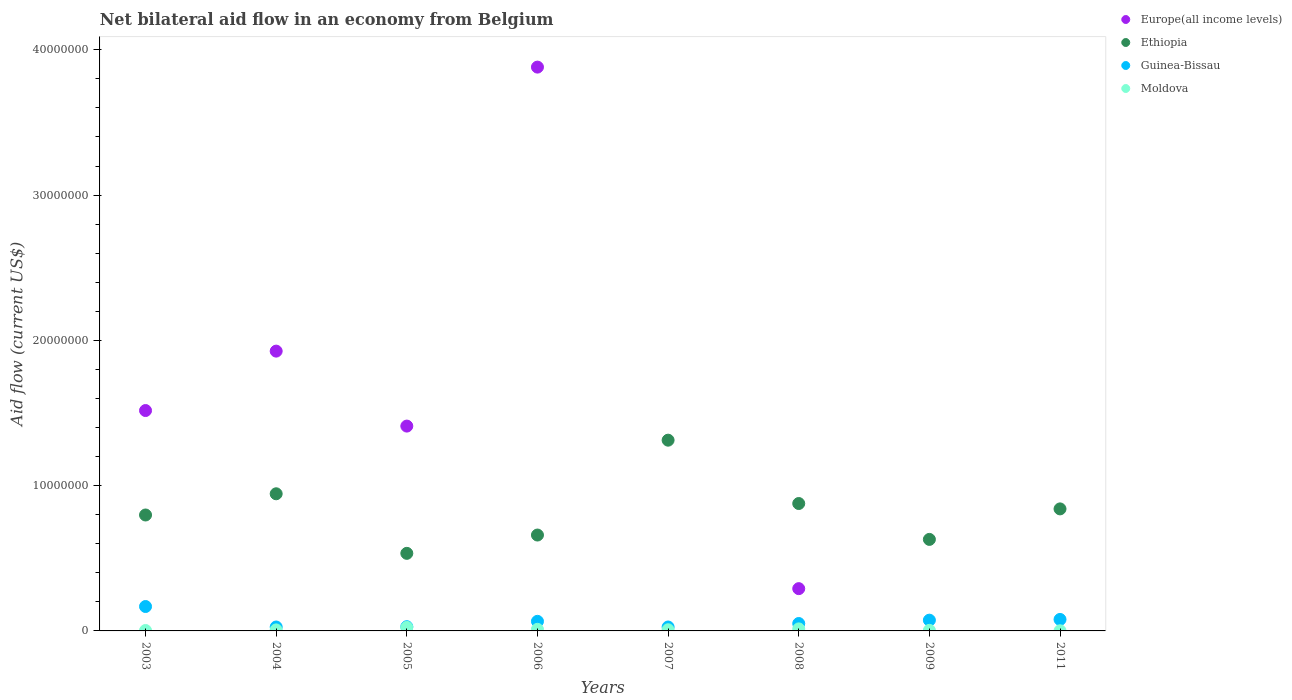How many different coloured dotlines are there?
Your answer should be compact. 4. Is the number of dotlines equal to the number of legend labels?
Make the answer very short. No. What is the net bilateral aid flow in Europe(all income levels) in 2009?
Give a very brief answer. 0. Across all years, what is the maximum net bilateral aid flow in Guinea-Bissau?
Offer a terse response. 1.68e+06. Across all years, what is the minimum net bilateral aid flow in Moldova?
Ensure brevity in your answer.  10000. What is the total net bilateral aid flow in Moldova in the graph?
Your answer should be very brief. 7.20e+05. What is the difference between the net bilateral aid flow in Moldova in 2006 and the net bilateral aid flow in Europe(all income levels) in 2009?
Offer a very short reply. 1.10e+05. What is the average net bilateral aid flow in Europe(all income levels) per year?
Ensure brevity in your answer.  1.13e+07. In the year 2004, what is the difference between the net bilateral aid flow in Europe(all income levels) and net bilateral aid flow in Guinea-Bissau?
Offer a very short reply. 1.90e+07. Is the net bilateral aid flow in Ethiopia in 2005 less than that in 2006?
Provide a succinct answer. Yes. What is the difference between the highest and the second highest net bilateral aid flow in Moldova?
Your answer should be compact. 1.00e+05. What is the difference between the highest and the lowest net bilateral aid flow in Europe(all income levels)?
Provide a succinct answer. 3.88e+07. Is it the case that in every year, the sum of the net bilateral aid flow in Guinea-Bissau and net bilateral aid flow in Moldova  is greater than the sum of net bilateral aid flow in Europe(all income levels) and net bilateral aid flow in Ethiopia?
Make the answer very short. No. Is it the case that in every year, the sum of the net bilateral aid flow in Moldova and net bilateral aid flow in Guinea-Bissau  is greater than the net bilateral aid flow in Europe(all income levels)?
Keep it short and to the point. No. Is the net bilateral aid flow in Guinea-Bissau strictly less than the net bilateral aid flow in Europe(all income levels) over the years?
Your answer should be very brief. No. How many dotlines are there?
Ensure brevity in your answer.  4. What is the difference between two consecutive major ticks on the Y-axis?
Provide a short and direct response. 1.00e+07. Are the values on the major ticks of Y-axis written in scientific E-notation?
Your answer should be compact. No. Does the graph contain grids?
Provide a succinct answer. No. Where does the legend appear in the graph?
Provide a succinct answer. Top right. What is the title of the graph?
Offer a very short reply. Net bilateral aid flow in an economy from Belgium. Does "Czech Republic" appear as one of the legend labels in the graph?
Make the answer very short. No. What is the label or title of the X-axis?
Your answer should be very brief. Years. What is the label or title of the Y-axis?
Ensure brevity in your answer.  Aid flow (current US$). What is the Aid flow (current US$) in Europe(all income levels) in 2003?
Your answer should be compact. 1.52e+07. What is the Aid flow (current US$) in Ethiopia in 2003?
Your answer should be compact. 7.98e+06. What is the Aid flow (current US$) of Guinea-Bissau in 2003?
Your answer should be very brief. 1.68e+06. What is the Aid flow (current US$) of Europe(all income levels) in 2004?
Your response must be concise. 1.93e+07. What is the Aid flow (current US$) of Ethiopia in 2004?
Your answer should be compact. 9.44e+06. What is the Aid flow (current US$) in Europe(all income levels) in 2005?
Your answer should be very brief. 1.41e+07. What is the Aid flow (current US$) of Ethiopia in 2005?
Your response must be concise. 5.34e+06. What is the Aid flow (current US$) of Guinea-Bissau in 2005?
Provide a short and direct response. 2.90e+05. What is the Aid flow (current US$) in Europe(all income levels) in 2006?
Keep it short and to the point. 3.88e+07. What is the Aid flow (current US$) in Ethiopia in 2006?
Your answer should be very brief. 6.60e+06. What is the Aid flow (current US$) of Guinea-Bissau in 2006?
Make the answer very short. 6.60e+05. What is the Aid flow (current US$) in Moldova in 2006?
Offer a very short reply. 1.10e+05. What is the Aid flow (current US$) in Ethiopia in 2007?
Keep it short and to the point. 1.31e+07. What is the Aid flow (current US$) in Guinea-Bissau in 2007?
Your answer should be compact. 2.70e+05. What is the Aid flow (current US$) of Moldova in 2007?
Your response must be concise. 8.00e+04. What is the Aid flow (current US$) in Europe(all income levels) in 2008?
Offer a terse response. 2.91e+06. What is the Aid flow (current US$) of Ethiopia in 2008?
Your response must be concise. 8.77e+06. What is the Aid flow (current US$) in Guinea-Bissau in 2008?
Offer a terse response. 5.10e+05. What is the Aid flow (current US$) of Moldova in 2008?
Your answer should be very brief. 1.40e+05. What is the Aid flow (current US$) in Ethiopia in 2009?
Provide a succinct answer. 6.30e+06. What is the Aid flow (current US$) of Guinea-Bissau in 2009?
Your response must be concise. 7.40e+05. What is the Aid flow (current US$) in Moldova in 2009?
Ensure brevity in your answer.  4.00e+04. What is the Aid flow (current US$) of Europe(all income levels) in 2011?
Ensure brevity in your answer.  0. What is the Aid flow (current US$) in Ethiopia in 2011?
Make the answer very short. 8.40e+06. What is the Aid flow (current US$) of Guinea-Bissau in 2011?
Your answer should be compact. 7.90e+05. What is the Aid flow (current US$) of Moldova in 2011?
Provide a short and direct response. 10000. Across all years, what is the maximum Aid flow (current US$) in Europe(all income levels)?
Give a very brief answer. 3.88e+07. Across all years, what is the maximum Aid flow (current US$) of Ethiopia?
Your answer should be very brief. 1.31e+07. Across all years, what is the maximum Aid flow (current US$) in Guinea-Bissau?
Ensure brevity in your answer.  1.68e+06. Across all years, what is the minimum Aid flow (current US$) of Europe(all income levels)?
Offer a very short reply. 0. Across all years, what is the minimum Aid flow (current US$) of Ethiopia?
Give a very brief answer. 5.34e+06. Across all years, what is the minimum Aid flow (current US$) of Guinea-Bissau?
Your answer should be compact. 2.70e+05. What is the total Aid flow (current US$) in Europe(all income levels) in the graph?
Provide a short and direct response. 9.02e+07. What is the total Aid flow (current US$) in Ethiopia in the graph?
Give a very brief answer. 6.60e+07. What is the total Aid flow (current US$) of Guinea-Bissau in the graph?
Ensure brevity in your answer.  5.21e+06. What is the total Aid flow (current US$) in Moldova in the graph?
Your answer should be very brief. 7.20e+05. What is the difference between the Aid flow (current US$) of Europe(all income levels) in 2003 and that in 2004?
Give a very brief answer. -4.09e+06. What is the difference between the Aid flow (current US$) in Ethiopia in 2003 and that in 2004?
Make the answer very short. -1.46e+06. What is the difference between the Aid flow (current US$) of Guinea-Bissau in 2003 and that in 2004?
Keep it short and to the point. 1.41e+06. What is the difference between the Aid flow (current US$) of Moldova in 2003 and that in 2004?
Your response must be concise. -4.00e+04. What is the difference between the Aid flow (current US$) in Europe(all income levels) in 2003 and that in 2005?
Keep it short and to the point. 1.07e+06. What is the difference between the Aid flow (current US$) of Ethiopia in 2003 and that in 2005?
Ensure brevity in your answer.  2.64e+06. What is the difference between the Aid flow (current US$) in Guinea-Bissau in 2003 and that in 2005?
Your answer should be very brief. 1.39e+06. What is the difference between the Aid flow (current US$) of Europe(all income levels) in 2003 and that in 2006?
Offer a terse response. -2.36e+07. What is the difference between the Aid flow (current US$) in Ethiopia in 2003 and that in 2006?
Provide a succinct answer. 1.38e+06. What is the difference between the Aid flow (current US$) of Guinea-Bissau in 2003 and that in 2006?
Provide a short and direct response. 1.02e+06. What is the difference between the Aid flow (current US$) of Moldova in 2003 and that in 2006?
Offer a terse response. -8.00e+04. What is the difference between the Aid flow (current US$) in Ethiopia in 2003 and that in 2007?
Provide a succinct answer. -5.15e+06. What is the difference between the Aid flow (current US$) of Guinea-Bissau in 2003 and that in 2007?
Keep it short and to the point. 1.41e+06. What is the difference between the Aid flow (current US$) in Moldova in 2003 and that in 2007?
Offer a very short reply. -5.00e+04. What is the difference between the Aid flow (current US$) in Europe(all income levels) in 2003 and that in 2008?
Keep it short and to the point. 1.23e+07. What is the difference between the Aid flow (current US$) in Ethiopia in 2003 and that in 2008?
Provide a short and direct response. -7.90e+05. What is the difference between the Aid flow (current US$) in Guinea-Bissau in 2003 and that in 2008?
Provide a short and direct response. 1.17e+06. What is the difference between the Aid flow (current US$) in Ethiopia in 2003 and that in 2009?
Offer a very short reply. 1.68e+06. What is the difference between the Aid flow (current US$) of Guinea-Bissau in 2003 and that in 2009?
Provide a succinct answer. 9.40e+05. What is the difference between the Aid flow (current US$) in Ethiopia in 2003 and that in 2011?
Give a very brief answer. -4.20e+05. What is the difference between the Aid flow (current US$) of Guinea-Bissau in 2003 and that in 2011?
Ensure brevity in your answer.  8.90e+05. What is the difference between the Aid flow (current US$) of Europe(all income levels) in 2004 and that in 2005?
Give a very brief answer. 5.16e+06. What is the difference between the Aid flow (current US$) of Ethiopia in 2004 and that in 2005?
Your answer should be very brief. 4.10e+06. What is the difference between the Aid flow (current US$) of Guinea-Bissau in 2004 and that in 2005?
Provide a short and direct response. -2.00e+04. What is the difference between the Aid flow (current US$) in Moldova in 2004 and that in 2005?
Offer a terse response. -1.70e+05. What is the difference between the Aid flow (current US$) in Europe(all income levels) in 2004 and that in 2006?
Give a very brief answer. -1.96e+07. What is the difference between the Aid flow (current US$) of Ethiopia in 2004 and that in 2006?
Keep it short and to the point. 2.84e+06. What is the difference between the Aid flow (current US$) of Guinea-Bissau in 2004 and that in 2006?
Ensure brevity in your answer.  -3.90e+05. What is the difference between the Aid flow (current US$) in Moldova in 2004 and that in 2006?
Keep it short and to the point. -4.00e+04. What is the difference between the Aid flow (current US$) of Ethiopia in 2004 and that in 2007?
Offer a very short reply. -3.69e+06. What is the difference between the Aid flow (current US$) in Guinea-Bissau in 2004 and that in 2007?
Offer a terse response. 0. What is the difference between the Aid flow (current US$) in Moldova in 2004 and that in 2007?
Ensure brevity in your answer.  -10000. What is the difference between the Aid flow (current US$) in Europe(all income levels) in 2004 and that in 2008?
Give a very brief answer. 1.64e+07. What is the difference between the Aid flow (current US$) of Ethiopia in 2004 and that in 2008?
Give a very brief answer. 6.70e+05. What is the difference between the Aid flow (current US$) of Guinea-Bissau in 2004 and that in 2008?
Your answer should be compact. -2.40e+05. What is the difference between the Aid flow (current US$) of Ethiopia in 2004 and that in 2009?
Make the answer very short. 3.14e+06. What is the difference between the Aid flow (current US$) of Guinea-Bissau in 2004 and that in 2009?
Give a very brief answer. -4.70e+05. What is the difference between the Aid flow (current US$) in Moldova in 2004 and that in 2009?
Your answer should be compact. 3.00e+04. What is the difference between the Aid flow (current US$) in Ethiopia in 2004 and that in 2011?
Make the answer very short. 1.04e+06. What is the difference between the Aid flow (current US$) in Guinea-Bissau in 2004 and that in 2011?
Ensure brevity in your answer.  -5.20e+05. What is the difference between the Aid flow (current US$) in Europe(all income levels) in 2005 and that in 2006?
Give a very brief answer. -2.47e+07. What is the difference between the Aid flow (current US$) of Ethiopia in 2005 and that in 2006?
Your answer should be compact. -1.26e+06. What is the difference between the Aid flow (current US$) of Guinea-Bissau in 2005 and that in 2006?
Offer a terse response. -3.70e+05. What is the difference between the Aid flow (current US$) of Moldova in 2005 and that in 2006?
Offer a very short reply. 1.30e+05. What is the difference between the Aid flow (current US$) in Ethiopia in 2005 and that in 2007?
Give a very brief answer. -7.79e+06. What is the difference between the Aid flow (current US$) in Guinea-Bissau in 2005 and that in 2007?
Make the answer very short. 2.00e+04. What is the difference between the Aid flow (current US$) of Moldova in 2005 and that in 2007?
Provide a succinct answer. 1.60e+05. What is the difference between the Aid flow (current US$) of Europe(all income levels) in 2005 and that in 2008?
Ensure brevity in your answer.  1.12e+07. What is the difference between the Aid flow (current US$) in Ethiopia in 2005 and that in 2008?
Provide a succinct answer. -3.43e+06. What is the difference between the Aid flow (current US$) of Guinea-Bissau in 2005 and that in 2008?
Offer a very short reply. -2.20e+05. What is the difference between the Aid flow (current US$) of Ethiopia in 2005 and that in 2009?
Offer a very short reply. -9.60e+05. What is the difference between the Aid flow (current US$) in Guinea-Bissau in 2005 and that in 2009?
Your response must be concise. -4.50e+05. What is the difference between the Aid flow (current US$) of Ethiopia in 2005 and that in 2011?
Provide a succinct answer. -3.06e+06. What is the difference between the Aid flow (current US$) in Guinea-Bissau in 2005 and that in 2011?
Provide a succinct answer. -5.00e+05. What is the difference between the Aid flow (current US$) of Ethiopia in 2006 and that in 2007?
Make the answer very short. -6.53e+06. What is the difference between the Aid flow (current US$) in Europe(all income levels) in 2006 and that in 2008?
Ensure brevity in your answer.  3.59e+07. What is the difference between the Aid flow (current US$) of Ethiopia in 2006 and that in 2008?
Your answer should be very brief. -2.17e+06. What is the difference between the Aid flow (current US$) in Guinea-Bissau in 2006 and that in 2009?
Provide a succinct answer. -8.00e+04. What is the difference between the Aid flow (current US$) of Moldova in 2006 and that in 2009?
Ensure brevity in your answer.  7.00e+04. What is the difference between the Aid flow (current US$) of Ethiopia in 2006 and that in 2011?
Ensure brevity in your answer.  -1.80e+06. What is the difference between the Aid flow (current US$) of Guinea-Bissau in 2006 and that in 2011?
Offer a terse response. -1.30e+05. What is the difference between the Aid flow (current US$) of Moldova in 2006 and that in 2011?
Make the answer very short. 1.00e+05. What is the difference between the Aid flow (current US$) of Ethiopia in 2007 and that in 2008?
Your answer should be compact. 4.36e+06. What is the difference between the Aid flow (current US$) in Guinea-Bissau in 2007 and that in 2008?
Your answer should be very brief. -2.40e+05. What is the difference between the Aid flow (current US$) of Moldova in 2007 and that in 2008?
Offer a very short reply. -6.00e+04. What is the difference between the Aid flow (current US$) of Ethiopia in 2007 and that in 2009?
Offer a terse response. 6.83e+06. What is the difference between the Aid flow (current US$) of Guinea-Bissau in 2007 and that in 2009?
Your response must be concise. -4.70e+05. What is the difference between the Aid flow (current US$) in Moldova in 2007 and that in 2009?
Give a very brief answer. 4.00e+04. What is the difference between the Aid flow (current US$) in Ethiopia in 2007 and that in 2011?
Provide a short and direct response. 4.73e+06. What is the difference between the Aid flow (current US$) of Guinea-Bissau in 2007 and that in 2011?
Keep it short and to the point. -5.20e+05. What is the difference between the Aid flow (current US$) of Moldova in 2007 and that in 2011?
Provide a succinct answer. 7.00e+04. What is the difference between the Aid flow (current US$) in Ethiopia in 2008 and that in 2009?
Provide a succinct answer. 2.47e+06. What is the difference between the Aid flow (current US$) of Moldova in 2008 and that in 2009?
Provide a short and direct response. 1.00e+05. What is the difference between the Aid flow (current US$) of Guinea-Bissau in 2008 and that in 2011?
Keep it short and to the point. -2.80e+05. What is the difference between the Aid flow (current US$) in Moldova in 2008 and that in 2011?
Give a very brief answer. 1.30e+05. What is the difference between the Aid flow (current US$) of Ethiopia in 2009 and that in 2011?
Provide a succinct answer. -2.10e+06. What is the difference between the Aid flow (current US$) in Europe(all income levels) in 2003 and the Aid flow (current US$) in Ethiopia in 2004?
Your answer should be very brief. 5.73e+06. What is the difference between the Aid flow (current US$) of Europe(all income levels) in 2003 and the Aid flow (current US$) of Guinea-Bissau in 2004?
Keep it short and to the point. 1.49e+07. What is the difference between the Aid flow (current US$) in Europe(all income levels) in 2003 and the Aid flow (current US$) in Moldova in 2004?
Ensure brevity in your answer.  1.51e+07. What is the difference between the Aid flow (current US$) in Ethiopia in 2003 and the Aid flow (current US$) in Guinea-Bissau in 2004?
Ensure brevity in your answer.  7.71e+06. What is the difference between the Aid flow (current US$) of Ethiopia in 2003 and the Aid flow (current US$) of Moldova in 2004?
Provide a short and direct response. 7.91e+06. What is the difference between the Aid flow (current US$) of Guinea-Bissau in 2003 and the Aid flow (current US$) of Moldova in 2004?
Provide a succinct answer. 1.61e+06. What is the difference between the Aid flow (current US$) in Europe(all income levels) in 2003 and the Aid flow (current US$) in Ethiopia in 2005?
Offer a terse response. 9.83e+06. What is the difference between the Aid flow (current US$) in Europe(all income levels) in 2003 and the Aid flow (current US$) in Guinea-Bissau in 2005?
Provide a succinct answer. 1.49e+07. What is the difference between the Aid flow (current US$) in Europe(all income levels) in 2003 and the Aid flow (current US$) in Moldova in 2005?
Your response must be concise. 1.49e+07. What is the difference between the Aid flow (current US$) in Ethiopia in 2003 and the Aid flow (current US$) in Guinea-Bissau in 2005?
Your response must be concise. 7.69e+06. What is the difference between the Aid flow (current US$) in Ethiopia in 2003 and the Aid flow (current US$) in Moldova in 2005?
Make the answer very short. 7.74e+06. What is the difference between the Aid flow (current US$) of Guinea-Bissau in 2003 and the Aid flow (current US$) of Moldova in 2005?
Provide a succinct answer. 1.44e+06. What is the difference between the Aid flow (current US$) in Europe(all income levels) in 2003 and the Aid flow (current US$) in Ethiopia in 2006?
Give a very brief answer. 8.57e+06. What is the difference between the Aid flow (current US$) in Europe(all income levels) in 2003 and the Aid flow (current US$) in Guinea-Bissau in 2006?
Your answer should be very brief. 1.45e+07. What is the difference between the Aid flow (current US$) in Europe(all income levels) in 2003 and the Aid flow (current US$) in Moldova in 2006?
Your response must be concise. 1.51e+07. What is the difference between the Aid flow (current US$) of Ethiopia in 2003 and the Aid flow (current US$) of Guinea-Bissau in 2006?
Your answer should be compact. 7.32e+06. What is the difference between the Aid flow (current US$) in Ethiopia in 2003 and the Aid flow (current US$) in Moldova in 2006?
Give a very brief answer. 7.87e+06. What is the difference between the Aid flow (current US$) of Guinea-Bissau in 2003 and the Aid flow (current US$) of Moldova in 2006?
Your response must be concise. 1.57e+06. What is the difference between the Aid flow (current US$) of Europe(all income levels) in 2003 and the Aid flow (current US$) of Ethiopia in 2007?
Provide a short and direct response. 2.04e+06. What is the difference between the Aid flow (current US$) of Europe(all income levels) in 2003 and the Aid flow (current US$) of Guinea-Bissau in 2007?
Offer a very short reply. 1.49e+07. What is the difference between the Aid flow (current US$) in Europe(all income levels) in 2003 and the Aid flow (current US$) in Moldova in 2007?
Your answer should be compact. 1.51e+07. What is the difference between the Aid flow (current US$) of Ethiopia in 2003 and the Aid flow (current US$) of Guinea-Bissau in 2007?
Provide a succinct answer. 7.71e+06. What is the difference between the Aid flow (current US$) in Ethiopia in 2003 and the Aid flow (current US$) in Moldova in 2007?
Your response must be concise. 7.90e+06. What is the difference between the Aid flow (current US$) in Guinea-Bissau in 2003 and the Aid flow (current US$) in Moldova in 2007?
Keep it short and to the point. 1.60e+06. What is the difference between the Aid flow (current US$) in Europe(all income levels) in 2003 and the Aid flow (current US$) in Ethiopia in 2008?
Give a very brief answer. 6.40e+06. What is the difference between the Aid flow (current US$) of Europe(all income levels) in 2003 and the Aid flow (current US$) of Guinea-Bissau in 2008?
Provide a succinct answer. 1.47e+07. What is the difference between the Aid flow (current US$) in Europe(all income levels) in 2003 and the Aid flow (current US$) in Moldova in 2008?
Your answer should be compact. 1.50e+07. What is the difference between the Aid flow (current US$) in Ethiopia in 2003 and the Aid flow (current US$) in Guinea-Bissau in 2008?
Offer a terse response. 7.47e+06. What is the difference between the Aid flow (current US$) of Ethiopia in 2003 and the Aid flow (current US$) of Moldova in 2008?
Provide a short and direct response. 7.84e+06. What is the difference between the Aid flow (current US$) in Guinea-Bissau in 2003 and the Aid flow (current US$) in Moldova in 2008?
Ensure brevity in your answer.  1.54e+06. What is the difference between the Aid flow (current US$) of Europe(all income levels) in 2003 and the Aid flow (current US$) of Ethiopia in 2009?
Your response must be concise. 8.87e+06. What is the difference between the Aid flow (current US$) in Europe(all income levels) in 2003 and the Aid flow (current US$) in Guinea-Bissau in 2009?
Offer a very short reply. 1.44e+07. What is the difference between the Aid flow (current US$) of Europe(all income levels) in 2003 and the Aid flow (current US$) of Moldova in 2009?
Your response must be concise. 1.51e+07. What is the difference between the Aid flow (current US$) of Ethiopia in 2003 and the Aid flow (current US$) of Guinea-Bissau in 2009?
Provide a succinct answer. 7.24e+06. What is the difference between the Aid flow (current US$) in Ethiopia in 2003 and the Aid flow (current US$) in Moldova in 2009?
Offer a very short reply. 7.94e+06. What is the difference between the Aid flow (current US$) of Guinea-Bissau in 2003 and the Aid flow (current US$) of Moldova in 2009?
Give a very brief answer. 1.64e+06. What is the difference between the Aid flow (current US$) in Europe(all income levels) in 2003 and the Aid flow (current US$) in Ethiopia in 2011?
Your response must be concise. 6.77e+06. What is the difference between the Aid flow (current US$) of Europe(all income levels) in 2003 and the Aid flow (current US$) of Guinea-Bissau in 2011?
Provide a short and direct response. 1.44e+07. What is the difference between the Aid flow (current US$) in Europe(all income levels) in 2003 and the Aid flow (current US$) in Moldova in 2011?
Your answer should be compact. 1.52e+07. What is the difference between the Aid flow (current US$) of Ethiopia in 2003 and the Aid flow (current US$) of Guinea-Bissau in 2011?
Your answer should be very brief. 7.19e+06. What is the difference between the Aid flow (current US$) in Ethiopia in 2003 and the Aid flow (current US$) in Moldova in 2011?
Make the answer very short. 7.97e+06. What is the difference between the Aid flow (current US$) of Guinea-Bissau in 2003 and the Aid flow (current US$) of Moldova in 2011?
Give a very brief answer. 1.67e+06. What is the difference between the Aid flow (current US$) in Europe(all income levels) in 2004 and the Aid flow (current US$) in Ethiopia in 2005?
Offer a terse response. 1.39e+07. What is the difference between the Aid flow (current US$) of Europe(all income levels) in 2004 and the Aid flow (current US$) of Guinea-Bissau in 2005?
Your response must be concise. 1.90e+07. What is the difference between the Aid flow (current US$) of Europe(all income levels) in 2004 and the Aid flow (current US$) of Moldova in 2005?
Your answer should be compact. 1.90e+07. What is the difference between the Aid flow (current US$) in Ethiopia in 2004 and the Aid flow (current US$) in Guinea-Bissau in 2005?
Make the answer very short. 9.15e+06. What is the difference between the Aid flow (current US$) of Ethiopia in 2004 and the Aid flow (current US$) of Moldova in 2005?
Your answer should be very brief. 9.20e+06. What is the difference between the Aid flow (current US$) of Guinea-Bissau in 2004 and the Aid flow (current US$) of Moldova in 2005?
Keep it short and to the point. 3.00e+04. What is the difference between the Aid flow (current US$) in Europe(all income levels) in 2004 and the Aid flow (current US$) in Ethiopia in 2006?
Your response must be concise. 1.27e+07. What is the difference between the Aid flow (current US$) in Europe(all income levels) in 2004 and the Aid flow (current US$) in Guinea-Bissau in 2006?
Your answer should be compact. 1.86e+07. What is the difference between the Aid flow (current US$) in Europe(all income levels) in 2004 and the Aid flow (current US$) in Moldova in 2006?
Offer a terse response. 1.92e+07. What is the difference between the Aid flow (current US$) in Ethiopia in 2004 and the Aid flow (current US$) in Guinea-Bissau in 2006?
Ensure brevity in your answer.  8.78e+06. What is the difference between the Aid flow (current US$) of Ethiopia in 2004 and the Aid flow (current US$) of Moldova in 2006?
Ensure brevity in your answer.  9.33e+06. What is the difference between the Aid flow (current US$) of Guinea-Bissau in 2004 and the Aid flow (current US$) of Moldova in 2006?
Ensure brevity in your answer.  1.60e+05. What is the difference between the Aid flow (current US$) of Europe(all income levels) in 2004 and the Aid flow (current US$) of Ethiopia in 2007?
Your answer should be very brief. 6.13e+06. What is the difference between the Aid flow (current US$) of Europe(all income levels) in 2004 and the Aid flow (current US$) of Guinea-Bissau in 2007?
Provide a short and direct response. 1.90e+07. What is the difference between the Aid flow (current US$) in Europe(all income levels) in 2004 and the Aid flow (current US$) in Moldova in 2007?
Offer a very short reply. 1.92e+07. What is the difference between the Aid flow (current US$) in Ethiopia in 2004 and the Aid flow (current US$) in Guinea-Bissau in 2007?
Your answer should be compact. 9.17e+06. What is the difference between the Aid flow (current US$) of Ethiopia in 2004 and the Aid flow (current US$) of Moldova in 2007?
Offer a terse response. 9.36e+06. What is the difference between the Aid flow (current US$) in Guinea-Bissau in 2004 and the Aid flow (current US$) in Moldova in 2007?
Your answer should be very brief. 1.90e+05. What is the difference between the Aid flow (current US$) in Europe(all income levels) in 2004 and the Aid flow (current US$) in Ethiopia in 2008?
Provide a succinct answer. 1.05e+07. What is the difference between the Aid flow (current US$) of Europe(all income levels) in 2004 and the Aid flow (current US$) of Guinea-Bissau in 2008?
Give a very brief answer. 1.88e+07. What is the difference between the Aid flow (current US$) in Europe(all income levels) in 2004 and the Aid flow (current US$) in Moldova in 2008?
Provide a succinct answer. 1.91e+07. What is the difference between the Aid flow (current US$) in Ethiopia in 2004 and the Aid flow (current US$) in Guinea-Bissau in 2008?
Ensure brevity in your answer.  8.93e+06. What is the difference between the Aid flow (current US$) in Ethiopia in 2004 and the Aid flow (current US$) in Moldova in 2008?
Make the answer very short. 9.30e+06. What is the difference between the Aid flow (current US$) in Europe(all income levels) in 2004 and the Aid flow (current US$) in Ethiopia in 2009?
Make the answer very short. 1.30e+07. What is the difference between the Aid flow (current US$) in Europe(all income levels) in 2004 and the Aid flow (current US$) in Guinea-Bissau in 2009?
Make the answer very short. 1.85e+07. What is the difference between the Aid flow (current US$) of Europe(all income levels) in 2004 and the Aid flow (current US$) of Moldova in 2009?
Offer a terse response. 1.92e+07. What is the difference between the Aid flow (current US$) of Ethiopia in 2004 and the Aid flow (current US$) of Guinea-Bissau in 2009?
Give a very brief answer. 8.70e+06. What is the difference between the Aid flow (current US$) of Ethiopia in 2004 and the Aid flow (current US$) of Moldova in 2009?
Provide a short and direct response. 9.40e+06. What is the difference between the Aid flow (current US$) of Europe(all income levels) in 2004 and the Aid flow (current US$) of Ethiopia in 2011?
Provide a short and direct response. 1.09e+07. What is the difference between the Aid flow (current US$) in Europe(all income levels) in 2004 and the Aid flow (current US$) in Guinea-Bissau in 2011?
Make the answer very short. 1.85e+07. What is the difference between the Aid flow (current US$) of Europe(all income levels) in 2004 and the Aid flow (current US$) of Moldova in 2011?
Your answer should be very brief. 1.92e+07. What is the difference between the Aid flow (current US$) in Ethiopia in 2004 and the Aid flow (current US$) in Guinea-Bissau in 2011?
Make the answer very short. 8.65e+06. What is the difference between the Aid flow (current US$) of Ethiopia in 2004 and the Aid flow (current US$) of Moldova in 2011?
Offer a terse response. 9.43e+06. What is the difference between the Aid flow (current US$) in Europe(all income levels) in 2005 and the Aid flow (current US$) in Ethiopia in 2006?
Your response must be concise. 7.50e+06. What is the difference between the Aid flow (current US$) of Europe(all income levels) in 2005 and the Aid flow (current US$) of Guinea-Bissau in 2006?
Give a very brief answer. 1.34e+07. What is the difference between the Aid flow (current US$) of Europe(all income levels) in 2005 and the Aid flow (current US$) of Moldova in 2006?
Your answer should be very brief. 1.40e+07. What is the difference between the Aid flow (current US$) in Ethiopia in 2005 and the Aid flow (current US$) in Guinea-Bissau in 2006?
Keep it short and to the point. 4.68e+06. What is the difference between the Aid flow (current US$) in Ethiopia in 2005 and the Aid flow (current US$) in Moldova in 2006?
Your answer should be very brief. 5.23e+06. What is the difference between the Aid flow (current US$) in Guinea-Bissau in 2005 and the Aid flow (current US$) in Moldova in 2006?
Make the answer very short. 1.80e+05. What is the difference between the Aid flow (current US$) in Europe(all income levels) in 2005 and the Aid flow (current US$) in Ethiopia in 2007?
Your answer should be compact. 9.70e+05. What is the difference between the Aid flow (current US$) of Europe(all income levels) in 2005 and the Aid flow (current US$) of Guinea-Bissau in 2007?
Keep it short and to the point. 1.38e+07. What is the difference between the Aid flow (current US$) in Europe(all income levels) in 2005 and the Aid flow (current US$) in Moldova in 2007?
Keep it short and to the point. 1.40e+07. What is the difference between the Aid flow (current US$) of Ethiopia in 2005 and the Aid flow (current US$) of Guinea-Bissau in 2007?
Your response must be concise. 5.07e+06. What is the difference between the Aid flow (current US$) in Ethiopia in 2005 and the Aid flow (current US$) in Moldova in 2007?
Your response must be concise. 5.26e+06. What is the difference between the Aid flow (current US$) of Guinea-Bissau in 2005 and the Aid flow (current US$) of Moldova in 2007?
Your response must be concise. 2.10e+05. What is the difference between the Aid flow (current US$) in Europe(all income levels) in 2005 and the Aid flow (current US$) in Ethiopia in 2008?
Provide a short and direct response. 5.33e+06. What is the difference between the Aid flow (current US$) of Europe(all income levels) in 2005 and the Aid flow (current US$) of Guinea-Bissau in 2008?
Your answer should be very brief. 1.36e+07. What is the difference between the Aid flow (current US$) of Europe(all income levels) in 2005 and the Aid flow (current US$) of Moldova in 2008?
Offer a very short reply. 1.40e+07. What is the difference between the Aid flow (current US$) in Ethiopia in 2005 and the Aid flow (current US$) in Guinea-Bissau in 2008?
Give a very brief answer. 4.83e+06. What is the difference between the Aid flow (current US$) in Ethiopia in 2005 and the Aid flow (current US$) in Moldova in 2008?
Your answer should be compact. 5.20e+06. What is the difference between the Aid flow (current US$) in Guinea-Bissau in 2005 and the Aid flow (current US$) in Moldova in 2008?
Provide a short and direct response. 1.50e+05. What is the difference between the Aid flow (current US$) of Europe(all income levels) in 2005 and the Aid flow (current US$) of Ethiopia in 2009?
Ensure brevity in your answer.  7.80e+06. What is the difference between the Aid flow (current US$) of Europe(all income levels) in 2005 and the Aid flow (current US$) of Guinea-Bissau in 2009?
Keep it short and to the point. 1.34e+07. What is the difference between the Aid flow (current US$) of Europe(all income levels) in 2005 and the Aid flow (current US$) of Moldova in 2009?
Give a very brief answer. 1.41e+07. What is the difference between the Aid flow (current US$) in Ethiopia in 2005 and the Aid flow (current US$) in Guinea-Bissau in 2009?
Your response must be concise. 4.60e+06. What is the difference between the Aid flow (current US$) of Ethiopia in 2005 and the Aid flow (current US$) of Moldova in 2009?
Ensure brevity in your answer.  5.30e+06. What is the difference between the Aid flow (current US$) in Guinea-Bissau in 2005 and the Aid flow (current US$) in Moldova in 2009?
Your answer should be compact. 2.50e+05. What is the difference between the Aid flow (current US$) of Europe(all income levels) in 2005 and the Aid flow (current US$) of Ethiopia in 2011?
Your response must be concise. 5.70e+06. What is the difference between the Aid flow (current US$) in Europe(all income levels) in 2005 and the Aid flow (current US$) in Guinea-Bissau in 2011?
Offer a very short reply. 1.33e+07. What is the difference between the Aid flow (current US$) in Europe(all income levels) in 2005 and the Aid flow (current US$) in Moldova in 2011?
Make the answer very short. 1.41e+07. What is the difference between the Aid flow (current US$) in Ethiopia in 2005 and the Aid flow (current US$) in Guinea-Bissau in 2011?
Give a very brief answer. 4.55e+06. What is the difference between the Aid flow (current US$) of Ethiopia in 2005 and the Aid flow (current US$) of Moldova in 2011?
Provide a short and direct response. 5.33e+06. What is the difference between the Aid flow (current US$) in Guinea-Bissau in 2005 and the Aid flow (current US$) in Moldova in 2011?
Make the answer very short. 2.80e+05. What is the difference between the Aid flow (current US$) of Europe(all income levels) in 2006 and the Aid flow (current US$) of Ethiopia in 2007?
Your response must be concise. 2.57e+07. What is the difference between the Aid flow (current US$) of Europe(all income levels) in 2006 and the Aid flow (current US$) of Guinea-Bissau in 2007?
Ensure brevity in your answer.  3.85e+07. What is the difference between the Aid flow (current US$) of Europe(all income levels) in 2006 and the Aid flow (current US$) of Moldova in 2007?
Offer a very short reply. 3.87e+07. What is the difference between the Aid flow (current US$) of Ethiopia in 2006 and the Aid flow (current US$) of Guinea-Bissau in 2007?
Ensure brevity in your answer.  6.33e+06. What is the difference between the Aid flow (current US$) of Ethiopia in 2006 and the Aid flow (current US$) of Moldova in 2007?
Keep it short and to the point. 6.52e+06. What is the difference between the Aid flow (current US$) of Guinea-Bissau in 2006 and the Aid flow (current US$) of Moldova in 2007?
Provide a succinct answer. 5.80e+05. What is the difference between the Aid flow (current US$) in Europe(all income levels) in 2006 and the Aid flow (current US$) in Ethiopia in 2008?
Your response must be concise. 3.00e+07. What is the difference between the Aid flow (current US$) of Europe(all income levels) in 2006 and the Aid flow (current US$) of Guinea-Bissau in 2008?
Your answer should be very brief. 3.83e+07. What is the difference between the Aid flow (current US$) of Europe(all income levels) in 2006 and the Aid flow (current US$) of Moldova in 2008?
Offer a terse response. 3.87e+07. What is the difference between the Aid flow (current US$) of Ethiopia in 2006 and the Aid flow (current US$) of Guinea-Bissau in 2008?
Keep it short and to the point. 6.09e+06. What is the difference between the Aid flow (current US$) of Ethiopia in 2006 and the Aid flow (current US$) of Moldova in 2008?
Ensure brevity in your answer.  6.46e+06. What is the difference between the Aid flow (current US$) of Guinea-Bissau in 2006 and the Aid flow (current US$) of Moldova in 2008?
Give a very brief answer. 5.20e+05. What is the difference between the Aid flow (current US$) in Europe(all income levels) in 2006 and the Aid flow (current US$) in Ethiopia in 2009?
Offer a terse response. 3.25e+07. What is the difference between the Aid flow (current US$) of Europe(all income levels) in 2006 and the Aid flow (current US$) of Guinea-Bissau in 2009?
Make the answer very short. 3.81e+07. What is the difference between the Aid flow (current US$) in Europe(all income levels) in 2006 and the Aid flow (current US$) in Moldova in 2009?
Give a very brief answer. 3.88e+07. What is the difference between the Aid flow (current US$) in Ethiopia in 2006 and the Aid flow (current US$) in Guinea-Bissau in 2009?
Keep it short and to the point. 5.86e+06. What is the difference between the Aid flow (current US$) of Ethiopia in 2006 and the Aid flow (current US$) of Moldova in 2009?
Your response must be concise. 6.56e+06. What is the difference between the Aid flow (current US$) in Guinea-Bissau in 2006 and the Aid flow (current US$) in Moldova in 2009?
Your answer should be compact. 6.20e+05. What is the difference between the Aid flow (current US$) in Europe(all income levels) in 2006 and the Aid flow (current US$) in Ethiopia in 2011?
Your answer should be very brief. 3.04e+07. What is the difference between the Aid flow (current US$) in Europe(all income levels) in 2006 and the Aid flow (current US$) in Guinea-Bissau in 2011?
Offer a very short reply. 3.80e+07. What is the difference between the Aid flow (current US$) in Europe(all income levels) in 2006 and the Aid flow (current US$) in Moldova in 2011?
Give a very brief answer. 3.88e+07. What is the difference between the Aid flow (current US$) of Ethiopia in 2006 and the Aid flow (current US$) of Guinea-Bissau in 2011?
Offer a very short reply. 5.81e+06. What is the difference between the Aid flow (current US$) of Ethiopia in 2006 and the Aid flow (current US$) of Moldova in 2011?
Offer a terse response. 6.59e+06. What is the difference between the Aid flow (current US$) in Guinea-Bissau in 2006 and the Aid flow (current US$) in Moldova in 2011?
Offer a very short reply. 6.50e+05. What is the difference between the Aid flow (current US$) in Ethiopia in 2007 and the Aid flow (current US$) in Guinea-Bissau in 2008?
Give a very brief answer. 1.26e+07. What is the difference between the Aid flow (current US$) in Ethiopia in 2007 and the Aid flow (current US$) in Moldova in 2008?
Your response must be concise. 1.30e+07. What is the difference between the Aid flow (current US$) of Ethiopia in 2007 and the Aid flow (current US$) of Guinea-Bissau in 2009?
Your response must be concise. 1.24e+07. What is the difference between the Aid flow (current US$) of Ethiopia in 2007 and the Aid flow (current US$) of Moldova in 2009?
Your response must be concise. 1.31e+07. What is the difference between the Aid flow (current US$) in Ethiopia in 2007 and the Aid flow (current US$) in Guinea-Bissau in 2011?
Keep it short and to the point. 1.23e+07. What is the difference between the Aid flow (current US$) of Ethiopia in 2007 and the Aid flow (current US$) of Moldova in 2011?
Provide a short and direct response. 1.31e+07. What is the difference between the Aid flow (current US$) in Europe(all income levels) in 2008 and the Aid flow (current US$) in Ethiopia in 2009?
Provide a short and direct response. -3.39e+06. What is the difference between the Aid flow (current US$) in Europe(all income levels) in 2008 and the Aid flow (current US$) in Guinea-Bissau in 2009?
Make the answer very short. 2.17e+06. What is the difference between the Aid flow (current US$) of Europe(all income levels) in 2008 and the Aid flow (current US$) of Moldova in 2009?
Offer a terse response. 2.87e+06. What is the difference between the Aid flow (current US$) of Ethiopia in 2008 and the Aid flow (current US$) of Guinea-Bissau in 2009?
Your answer should be compact. 8.03e+06. What is the difference between the Aid flow (current US$) of Ethiopia in 2008 and the Aid flow (current US$) of Moldova in 2009?
Provide a succinct answer. 8.73e+06. What is the difference between the Aid flow (current US$) of Guinea-Bissau in 2008 and the Aid flow (current US$) of Moldova in 2009?
Give a very brief answer. 4.70e+05. What is the difference between the Aid flow (current US$) of Europe(all income levels) in 2008 and the Aid flow (current US$) of Ethiopia in 2011?
Your response must be concise. -5.49e+06. What is the difference between the Aid flow (current US$) in Europe(all income levels) in 2008 and the Aid flow (current US$) in Guinea-Bissau in 2011?
Your response must be concise. 2.12e+06. What is the difference between the Aid flow (current US$) in Europe(all income levels) in 2008 and the Aid flow (current US$) in Moldova in 2011?
Provide a short and direct response. 2.90e+06. What is the difference between the Aid flow (current US$) in Ethiopia in 2008 and the Aid flow (current US$) in Guinea-Bissau in 2011?
Make the answer very short. 7.98e+06. What is the difference between the Aid flow (current US$) of Ethiopia in 2008 and the Aid flow (current US$) of Moldova in 2011?
Your answer should be very brief. 8.76e+06. What is the difference between the Aid flow (current US$) of Guinea-Bissau in 2008 and the Aid flow (current US$) of Moldova in 2011?
Offer a very short reply. 5.00e+05. What is the difference between the Aid flow (current US$) of Ethiopia in 2009 and the Aid flow (current US$) of Guinea-Bissau in 2011?
Give a very brief answer. 5.51e+06. What is the difference between the Aid flow (current US$) in Ethiopia in 2009 and the Aid flow (current US$) in Moldova in 2011?
Give a very brief answer. 6.29e+06. What is the difference between the Aid flow (current US$) of Guinea-Bissau in 2009 and the Aid flow (current US$) of Moldova in 2011?
Provide a succinct answer. 7.30e+05. What is the average Aid flow (current US$) in Europe(all income levels) per year?
Give a very brief answer. 1.13e+07. What is the average Aid flow (current US$) in Ethiopia per year?
Ensure brevity in your answer.  8.24e+06. What is the average Aid flow (current US$) of Guinea-Bissau per year?
Your answer should be compact. 6.51e+05. In the year 2003, what is the difference between the Aid flow (current US$) of Europe(all income levels) and Aid flow (current US$) of Ethiopia?
Offer a very short reply. 7.19e+06. In the year 2003, what is the difference between the Aid flow (current US$) of Europe(all income levels) and Aid flow (current US$) of Guinea-Bissau?
Make the answer very short. 1.35e+07. In the year 2003, what is the difference between the Aid flow (current US$) of Europe(all income levels) and Aid flow (current US$) of Moldova?
Provide a short and direct response. 1.51e+07. In the year 2003, what is the difference between the Aid flow (current US$) in Ethiopia and Aid flow (current US$) in Guinea-Bissau?
Keep it short and to the point. 6.30e+06. In the year 2003, what is the difference between the Aid flow (current US$) of Ethiopia and Aid flow (current US$) of Moldova?
Ensure brevity in your answer.  7.95e+06. In the year 2003, what is the difference between the Aid flow (current US$) in Guinea-Bissau and Aid flow (current US$) in Moldova?
Provide a short and direct response. 1.65e+06. In the year 2004, what is the difference between the Aid flow (current US$) in Europe(all income levels) and Aid flow (current US$) in Ethiopia?
Keep it short and to the point. 9.82e+06. In the year 2004, what is the difference between the Aid flow (current US$) of Europe(all income levels) and Aid flow (current US$) of Guinea-Bissau?
Your answer should be very brief. 1.90e+07. In the year 2004, what is the difference between the Aid flow (current US$) of Europe(all income levels) and Aid flow (current US$) of Moldova?
Provide a succinct answer. 1.92e+07. In the year 2004, what is the difference between the Aid flow (current US$) in Ethiopia and Aid flow (current US$) in Guinea-Bissau?
Your answer should be very brief. 9.17e+06. In the year 2004, what is the difference between the Aid flow (current US$) in Ethiopia and Aid flow (current US$) in Moldova?
Offer a very short reply. 9.37e+06. In the year 2004, what is the difference between the Aid flow (current US$) in Guinea-Bissau and Aid flow (current US$) in Moldova?
Make the answer very short. 2.00e+05. In the year 2005, what is the difference between the Aid flow (current US$) in Europe(all income levels) and Aid flow (current US$) in Ethiopia?
Offer a very short reply. 8.76e+06. In the year 2005, what is the difference between the Aid flow (current US$) of Europe(all income levels) and Aid flow (current US$) of Guinea-Bissau?
Offer a very short reply. 1.38e+07. In the year 2005, what is the difference between the Aid flow (current US$) of Europe(all income levels) and Aid flow (current US$) of Moldova?
Keep it short and to the point. 1.39e+07. In the year 2005, what is the difference between the Aid flow (current US$) of Ethiopia and Aid flow (current US$) of Guinea-Bissau?
Keep it short and to the point. 5.05e+06. In the year 2005, what is the difference between the Aid flow (current US$) in Ethiopia and Aid flow (current US$) in Moldova?
Offer a very short reply. 5.10e+06. In the year 2006, what is the difference between the Aid flow (current US$) of Europe(all income levels) and Aid flow (current US$) of Ethiopia?
Make the answer very short. 3.22e+07. In the year 2006, what is the difference between the Aid flow (current US$) in Europe(all income levels) and Aid flow (current US$) in Guinea-Bissau?
Give a very brief answer. 3.82e+07. In the year 2006, what is the difference between the Aid flow (current US$) of Europe(all income levels) and Aid flow (current US$) of Moldova?
Your response must be concise. 3.87e+07. In the year 2006, what is the difference between the Aid flow (current US$) of Ethiopia and Aid flow (current US$) of Guinea-Bissau?
Your response must be concise. 5.94e+06. In the year 2006, what is the difference between the Aid flow (current US$) in Ethiopia and Aid flow (current US$) in Moldova?
Your answer should be compact. 6.49e+06. In the year 2007, what is the difference between the Aid flow (current US$) in Ethiopia and Aid flow (current US$) in Guinea-Bissau?
Offer a very short reply. 1.29e+07. In the year 2007, what is the difference between the Aid flow (current US$) in Ethiopia and Aid flow (current US$) in Moldova?
Give a very brief answer. 1.30e+07. In the year 2007, what is the difference between the Aid flow (current US$) in Guinea-Bissau and Aid flow (current US$) in Moldova?
Your answer should be compact. 1.90e+05. In the year 2008, what is the difference between the Aid flow (current US$) of Europe(all income levels) and Aid flow (current US$) of Ethiopia?
Ensure brevity in your answer.  -5.86e+06. In the year 2008, what is the difference between the Aid flow (current US$) in Europe(all income levels) and Aid flow (current US$) in Guinea-Bissau?
Keep it short and to the point. 2.40e+06. In the year 2008, what is the difference between the Aid flow (current US$) of Europe(all income levels) and Aid flow (current US$) of Moldova?
Give a very brief answer. 2.77e+06. In the year 2008, what is the difference between the Aid flow (current US$) in Ethiopia and Aid flow (current US$) in Guinea-Bissau?
Your answer should be compact. 8.26e+06. In the year 2008, what is the difference between the Aid flow (current US$) of Ethiopia and Aid flow (current US$) of Moldova?
Your answer should be very brief. 8.63e+06. In the year 2009, what is the difference between the Aid flow (current US$) of Ethiopia and Aid flow (current US$) of Guinea-Bissau?
Keep it short and to the point. 5.56e+06. In the year 2009, what is the difference between the Aid flow (current US$) in Ethiopia and Aid flow (current US$) in Moldova?
Ensure brevity in your answer.  6.26e+06. In the year 2011, what is the difference between the Aid flow (current US$) in Ethiopia and Aid flow (current US$) in Guinea-Bissau?
Offer a very short reply. 7.61e+06. In the year 2011, what is the difference between the Aid flow (current US$) in Ethiopia and Aid flow (current US$) in Moldova?
Give a very brief answer. 8.39e+06. In the year 2011, what is the difference between the Aid flow (current US$) of Guinea-Bissau and Aid flow (current US$) of Moldova?
Offer a very short reply. 7.80e+05. What is the ratio of the Aid flow (current US$) in Europe(all income levels) in 2003 to that in 2004?
Keep it short and to the point. 0.79. What is the ratio of the Aid flow (current US$) of Ethiopia in 2003 to that in 2004?
Your answer should be very brief. 0.85. What is the ratio of the Aid flow (current US$) in Guinea-Bissau in 2003 to that in 2004?
Give a very brief answer. 6.22. What is the ratio of the Aid flow (current US$) of Moldova in 2003 to that in 2004?
Your answer should be compact. 0.43. What is the ratio of the Aid flow (current US$) in Europe(all income levels) in 2003 to that in 2005?
Offer a terse response. 1.08. What is the ratio of the Aid flow (current US$) in Ethiopia in 2003 to that in 2005?
Offer a very short reply. 1.49. What is the ratio of the Aid flow (current US$) in Guinea-Bissau in 2003 to that in 2005?
Keep it short and to the point. 5.79. What is the ratio of the Aid flow (current US$) of Moldova in 2003 to that in 2005?
Provide a short and direct response. 0.12. What is the ratio of the Aid flow (current US$) of Europe(all income levels) in 2003 to that in 2006?
Offer a terse response. 0.39. What is the ratio of the Aid flow (current US$) of Ethiopia in 2003 to that in 2006?
Make the answer very short. 1.21. What is the ratio of the Aid flow (current US$) of Guinea-Bissau in 2003 to that in 2006?
Offer a terse response. 2.55. What is the ratio of the Aid flow (current US$) in Moldova in 2003 to that in 2006?
Offer a terse response. 0.27. What is the ratio of the Aid flow (current US$) of Ethiopia in 2003 to that in 2007?
Offer a very short reply. 0.61. What is the ratio of the Aid flow (current US$) of Guinea-Bissau in 2003 to that in 2007?
Make the answer very short. 6.22. What is the ratio of the Aid flow (current US$) of Europe(all income levels) in 2003 to that in 2008?
Provide a short and direct response. 5.21. What is the ratio of the Aid flow (current US$) of Ethiopia in 2003 to that in 2008?
Give a very brief answer. 0.91. What is the ratio of the Aid flow (current US$) in Guinea-Bissau in 2003 to that in 2008?
Offer a terse response. 3.29. What is the ratio of the Aid flow (current US$) in Moldova in 2003 to that in 2008?
Give a very brief answer. 0.21. What is the ratio of the Aid flow (current US$) in Ethiopia in 2003 to that in 2009?
Offer a terse response. 1.27. What is the ratio of the Aid flow (current US$) of Guinea-Bissau in 2003 to that in 2009?
Provide a succinct answer. 2.27. What is the ratio of the Aid flow (current US$) of Moldova in 2003 to that in 2009?
Provide a succinct answer. 0.75. What is the ratio of the Aid flow (current US$) of Ethiopia in 2003 to that in 2011?
Make the answer very short. 0.95. What is the ratio of the Aid flow (current US$) in Guinea-Bissau in 2003 to that in 2011?
Provide a short and direct response. 2.13. What is the ratio of the Aid flow (current US$) of Moldova in 2003 to that in 2011?
Your answer should be compact. 3. What is the ratio of the Aid flow (current US$) in Europe(all income levels) in 2004 to that in 2005?
Make the answer very short. 1.37. What is the ratio of the Aid flow (current US$) in Ethiopia in 2004 to that in 2005?
Your answer should be compact. 1.77. What is the ratio of the Aid flow (current US$) of Guinea-Bissau in 2004 to that in 2005?
Your answer should be compact. 0.93. What is the ratio of the Aid flow (current US$) of Moldova in 2004 to that in 2005?
Your answer should be compact. 0.29. What is the ratio of the Aid flow (current US$) in Europe(all income levels) in 2004 to that in 2006?
Provide a succinct answer. 0.5. What is the ratio of the Aid flow (current US$) in Ethiopia in 2004 to that in 2006?
Your answer should be very brief. 1.43. What is the ratio of the Aid flow (current US$) of Guinea-Bissau in 2004 to that in 2006?
Offer a very short reply. 0.41. What is the ratio of the Aid flow (current US$) in Moldova in 2004 to that in 2006?
Give a very brief answer. 0.64. What is the ratio of the Aid flow (current US$) in Ethiopia in 2004 to that in 2007?
Your answer should be very brief. 0.72. What is the ratio of the Aid flow (current US$) in Guinea-Bissau in 2004 to that in 2007?
Your response must be concise. 1. What is the ratio of the Aid flow (current US$) of Europe(all income levels) in 2004 to that in 2008?
Your answer should be compact. 6.62. What is the ratio of the Aid flow (current US$) of Ethiopia in 2004 to that in 2008?
Your answer should be compact. 1.08. What is the ratio of the Aid flow (current US$) in Guinea-Bissau in 2004 to that in 2008?
Keep it short and to the point. 0.53. What is the ratio of the Aid flow (current US$) in Moldova in 2004 to that in 2008?
Your response must be concise. 0.5. What is the ratio of the Aid flow (current US$) of Ethiopia in 2004 to that in 2009?
Provide a succinct answer. 1.5. What is the ratio of the Aid flow (current US$) of Guinea-Bissau in 2004 to that in 2009?
Keep it short and to the point. 0.36. What is the ratio of the Aid flow (current US$) of Ethiopia in 2004 to that in 2011?
Your answer should be compact. 1.12. What is the ratio of the Aid flow (current US$) in Guinea-Bissau in 2004 to that in 2011?
Give a very brief answer. 0.34. What is the ratio of the Aid flow (current US$) of Moldova in 2004 to that in 2011?
Give a very brief answer. 7. What is the ratio of the Aid flow (current US$) of Europe(all income levels) in 2005 to that in 2006?
Ensure brevity in your answer.  0.36. What is the ratio of the Aid flow (current US$) of Ethiopia in 2005 to that in 2006?
Keep it short and to the point. 0.81. What is the ratio of the Aid flow (current US$) in Guinea-Bissau in 2005 to that in 2006?
Provide a short and direct response. 0.44. What is the ratio of the Aid flow (current US$) of Moldova in 2005 to that in 2006?
Make the answer very short. 2.18. What is the ratio of the Aid flow (current US$) of Ethiopia in 2005 to that in 2007?
Offer a terse response. 0.41. What is the ratio of the Aid flow (current US$) of Guinea-Bissau in 2005 to that in 2007?
Your answer should be compact. 1.07. What is the ratio of the Aid flow (current US$) in Europe(all income levels) in 2005 to that in 2008?
Make the answer very short. 4.85. What is the ratio of the Aid flow (current US$) in Ethiopia in 2005 to that in 2008?
Provide a short and direct response. 0.61. What is the ratio of the Aid flow (current US$) in Guinea-Bissau in 2005 to that in 2008?
Offer a very short reply. 0.57. What is the ratio of the Aid flow (current US$) in Moldova in 2005 to that in 2008?
Keep it short and to the point. 1.71. What is the ratio of the Aid flow (current US$) in Ethiopia in 2005 to that in 2009?
Your answer should be compact. 0.85. What is the ratio of the Aid flow (current US$) in Guinea-Bissau in 2005 to that in 2009?
Provide a short and direct response. 0.39. What is the ratio of the Aid flow (current US$) in Moldova in 2005 to that in 2009?
Offer a terse response. 6. What is the ratio of the Aid flow (current US$) in Ethiopia in 2005 to that in 2011?
Keep it short and to the point. 0.64. What is the ratio of the Aid flow (current US$) in Guinea-Bissau in 2005 to that in 2011?
Provide a short and direct response. 0.37. What is the ratio of the Aid flow (current US$) of Ethiopia in 2006 to that in 2007?
Ensure brevity in your answer.  0.5. What is the ratio of the Aid flow (current US$) of Guinea-Bissau in 2006 to that in 2007?
Offer a very short reply. 2.44. What is the ratio of the Aid flow (current US$) of Moldova in 2006 to that in 2007?
Keep it short and to the point. 1.38. What is the ratio of the Aid flow (current US$) of Europe(all income levels) in 2006 to that in 2008?
Offer a very short reply. 13.34. What is the ratio of the Aid flow (current US$) in Ethiopia in 2006 to that in 2008?
Offer a terse response. 0.75. What is the ratio of the Aid flow (current US$) of Guinea-Bissau in 2006 to that in 2008?
Provide a short and direct response. 1.29. What is the ratio of the Aid flow (current US$) of Moldova in 2006 to that in 2008?
Offer a very short reply. 0.79. What is the ratio of the Aid flow (current US$) in Ethiopia in 2006 to that in 2009?
Provide a succinct answer. 1.05. What is the ratio of the Aid flow (current US$) of Guinea-Bissau in 2006 to that in 2009?
Provide a succinct answer. 0.89. What is the ratio of the Aid flow (current US$) in Moldova in 2006 to that in 2009?
Your response must be concise. 2.75. What is the ratio of the Aid flow (current US$) in Ethiopia in 2006 to that in 2011?
Your answer should be compact. 0.79. What is the ratio of the Aid flow (current US$) of Guinea-Bissau in 2006 to that in 2011?
Provide a succinct answer. 0.84. What is the ratio of the Aid flow (current US$) of Moldova in 2006 to that in 2011?
Offer a terse response. 11. What is the ratio of the Aid flow (current US$) of Ethiopia in 2007 to that in 2008?
Give a very brief answer. 1.5. What is the ratio of the Aid flow (current US$) of Guinea-Bissau in 2007 to that in 2008?
Your answer should be very brief. 0.53. What is the ratio of the Aid flow (current US$) in Ethiopia in 2007 to that in 2009?
Make the answer very short. 2.08. What is the ratio of the Aid flow (current US$) in Guinea-Bissau in 2007 to that in 2009?
Your answer should be very brief. 0.36. What is the ratio of the Aid flow (current US$) of Ethiopia in 2007 to that in 2011?
Make the answer very short. 1.56. What is the ratio of the Aid flow (current US$) of Guinea-Bissau in 2007 to that in 2011?
Your answer should be compact. 0.34. What is the ratio of the Aid flow (current US$) in Ethiopia in 2008 to that in 2009?
Provide a succinct answer. 1.39. What is the ratio of the Aid flow (current US$) in Guinea-Bissau in 2008 to that in 2009?
Offer a terse response. 0.69. What is the ratio of the Aid flow (current US$) in Ethiopia in 2008 to that in 2011?
Give a very brief answer. 1.04. What is the ratio of the Aid flow (current US$) in Guinea-Bissau in 2008 to that in 2011?
Your answer should be very brief. 0.65. What is the ratio of the Aid flow (current US$) in Ethiopia in 2009 to that in 2011?
Give a very brief answer. 0.75. What is the ratio of the Aid flow (current US$) of Guinea-Bissau in 2009 to that in 2011?
Provide a short and direct response. 0.94. What is the ratio of the Aid flow (current US$) of Moldova in 2009 to that in 2011?
Ensure brevity in your answer.  4. What is the difference between the highest and the second highest Aid flow (current US$) in Europe(all income levels)?
Provide a succinct answer. 1.96e+07. What is the difference between the highest and the second highest Aid flow (current US$) in Ethiopia?
Keep it short and to the point. 3.69e+06. What is the difference between the highest and the second highest Aid flow (current US$) of Guinea-Bissau?
Offer a very short reply. 8.90e+05. What is the difference between the highest and the lowest Aid flow (current US$) in Europe(all income levels)?
Ensure brevity in your answer.  3.88e+07. What is the difference between the highest and the lowest Aid flow (current US$) in Ethiopia?
Offer a very short reply. 7.79e+06. What is the difference between the highest and the lowest Aid flow (current US$) in Guinea-Bissau?
Your answer should be very brief. 1.41e+06. What is the difference between the highest and the lowest Aid flow (current US$) in Moldova?
Offer a very short reply. 2.30e+05. 